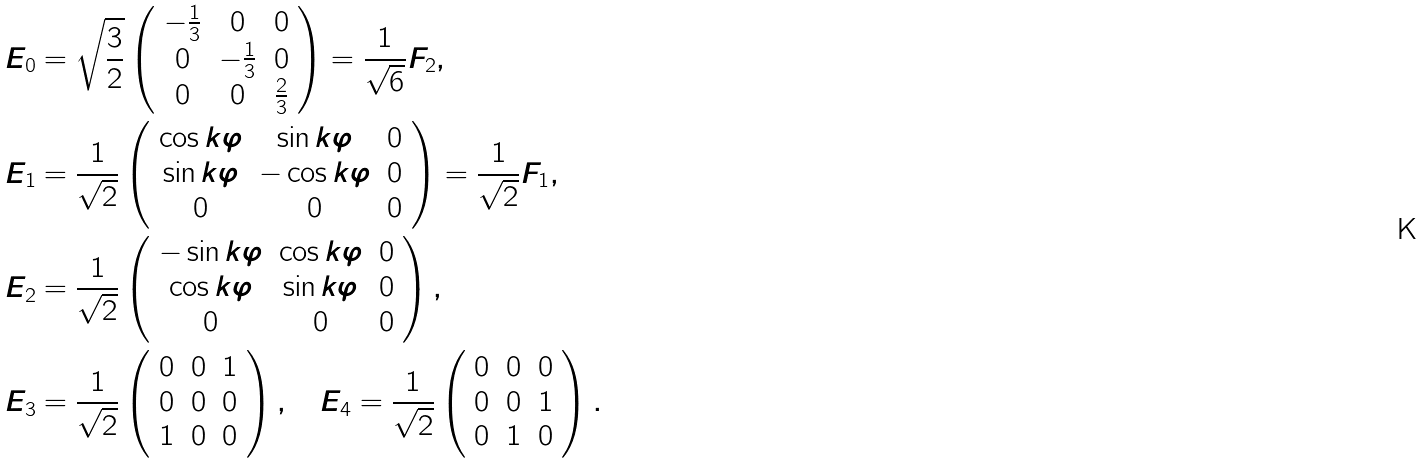<formula> <loc_0><loc_0><loc_500><loc_500>E _ { 0 } & = \sqrt { \frac { 3 } { 2 } } \left ( \begin{array} { c c c } - \frac { 1 } { 3 } & 0 & 0 \\ 0 & - \frac { 1 } { 3 } & 0 \\ 0 & 0 & \frac { 2 } { 3 } \\ \end{array} \right ) = \frac { 1 } { \sqrt { 6 } } F _ { 2 } , \\ E _ { 1 } & = \frac { 1 } { \sqrt { 2 } } \left ( \begin{array} { c c c } \cos k \varphi & \sin k \varphi & 0 \\ \sin k \varphi & - \cos k \varphi & 0 \\ 0 & 0 & 0 \\ \end{array} \right ) = \frac { 1 } { \sqrt { 2 } } F _ { 1 } , \\ E _ { 2 } & = \frac { 1 } { \sqrt { 2 } } \left ( \begin{array} { c c c } - \sin k \varphi & \cos k \varphi & 0 \\ \cos k \varphi & \sin k \varphi & 0 \\ 0 & 0 & 0 \\ \end{array} \right ) , \\ E _ { 3 } & = \frac { 1 } { \sqrt { 2 } } \left ( \begin{array} { c c c } 0 & 0 & 1 \\ 0 & 0 & 0 \\ 1 & 0 & 0 \\ \end{array} \right ) , \quad E _ { 4 } = \frac { 1 } { \sqrt { 2 } } \left ( \begin{array} { c c c } 0 & 0 & 0 \\ 0 & 0 & 1 \\ 0 & 1 & 0 \\ \end{array} \right ) .</formula> 